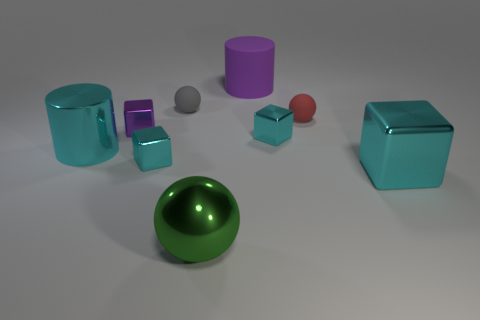How many objects are either small things behind the tiny red matte object or purple objects?
Your answer should be very brief. 3. Are there more rubber cylinders than red rubber cylinders?
Your answer should be compact. Yes. Is there a red sphere of the same size as the purple cylinder?
Keep it short and to the point. No. What number of objects are metal things left of the large metallic ball or blocks to the left of the big rubber cylinder?
Offer a terse response. 3. What is the color of the large metallic thing on the right side of the purple thing that is to the right of the large sphere?
Provide a succinct answer. Cyan. What color is the big cube that is the same material as the big green sphere?
Offer a terse response. Cyan. What number of small metal objects have the same color as the big matte object?
Provide a short and direct response. 1. What number of objects are either tiny blue metal blocks or cyan shiny objects?
Offer a very short reply. 4. What shape is the purple object that is the same size as the red rubber sphere?
Ensure brevity in your answer.  Cube. What number of large objects are both in front of the tiny red ball and to the left of the big cyan block?
Provide a succinct answer. 2. 